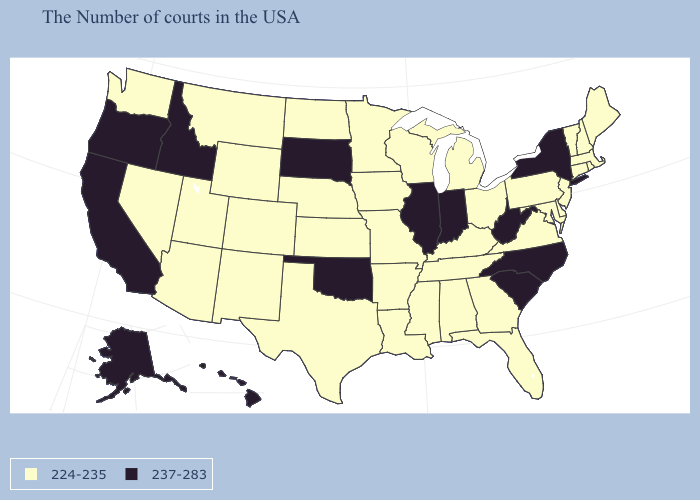Name the states that have a value in the range 237-283?
Quick response, please. New York, North Carolina, South Carolina, West Virginia, Indiana, Illinois, Oklahoma, South Dakota, Idaho, California, Oregon, Alaska, Hawaii. What is the value of South Dakota?
Short answer required. 237-283. Does Indiana have the highest value in the MidWest?
Concise answer only. Yes. Does the first symbol in the legend represent the smallest category?
Write a very short answer. Yes. Which states have the lowest value in the South?
Concise answer only. Delaware, Maryland, Virginia, Florida, Georgia, Kentucky, Alabama, Tennessee, Mississippi, Louisiana, Arkansas, Texas. Which states have the highest value in the USA?
Short answer required. New York, North Carolina, South Carolina, West Virginia, Indiana, Illinois, Oklahoma, South Dakota, Idaho, California, Oregon, Alaska, Hawaii. Which states have the lowest value in the USA?
Be succinct. Maine, Massachusetts, Rhode Island, New Hampshire, Vermont, Connecticut, New Jersey, Delaware, Maryland, Pennsylvania, Virginia, Ohio, Florida, Georgia, Michigan, Kentucky, Alabama, Tennessee, Wisconsin, Mississippi, Louisiana, Missouri, Arkansas, Minnesota, Iowa, Kansas, Nebraska, Texas, North Dakota, Wyoming, Colorado, New Mexico, Utah, Montana, Arizona, Nevada, Washington. Among the states that border Texas , does Oklahoma have the highest value?
Concise answer only. Yes. What is the lowest value in the MidWest?
Give a very brief answer. 224-235. What is the highest value in the USA?
Answer briefly. 237-283. What is the value of Nebraska?
Give a very brief answer. 224-235. What is the highest value in the USA?
Short answer required. 237-283. What is the value of Kentucky?
Keep it brief. 224-235. Which states have the lowest value in the USA?
Short answer required. Maine, Massachusetts, Rhode Island, New Hampshire, Vermont, Connecticut, New Jersey, Delaware, Maryland, Pennsylvania, Virginia, Ohio, Florida, Georgia, Michigan, Kentucky, Alabama, Tennessee, Wisconsin, Mississippi, Louisiana, Missouri, Arkansas, Minnesota, Iowa, Kansas, Nebraska, Texas, North Dakota, Wyoming, Colorado, New Mexico, Utah, Montana, Arizona, Nevada, Washington. 